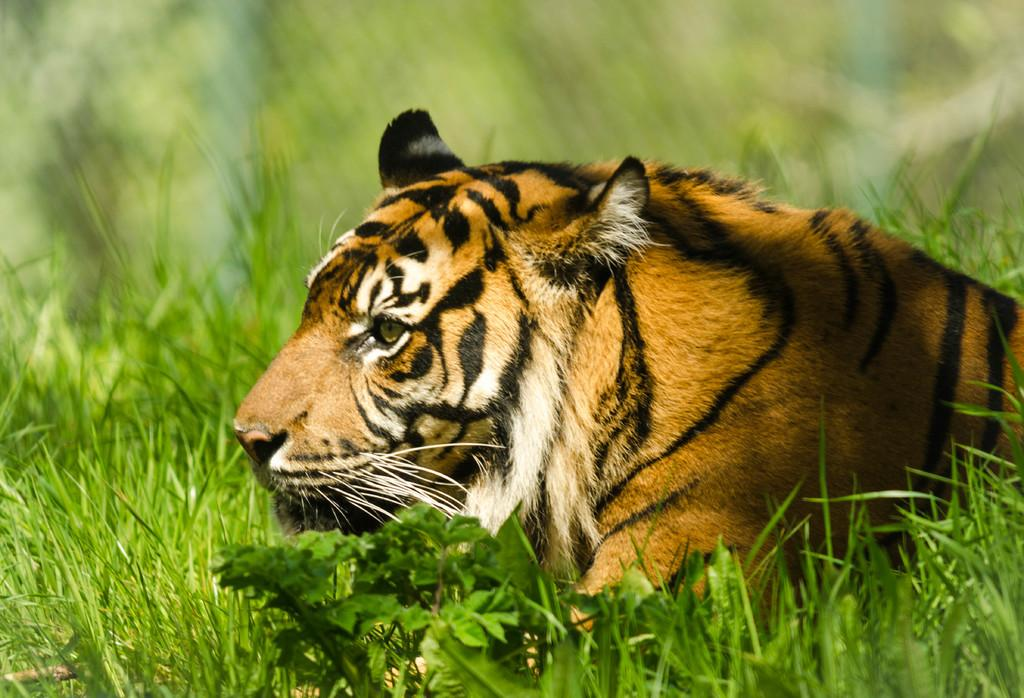What type of animal is in the image? There is a tiger in the image. What type of vegetation can be seen in the image? There are leaves and grass in the image. How would you describe the background of the image? The background of the image is blurry. What type of potato is being used to power the engine in the image? There is no potato or engine present in the image; it features a tiger, leaves, grass, and a blurry background. 